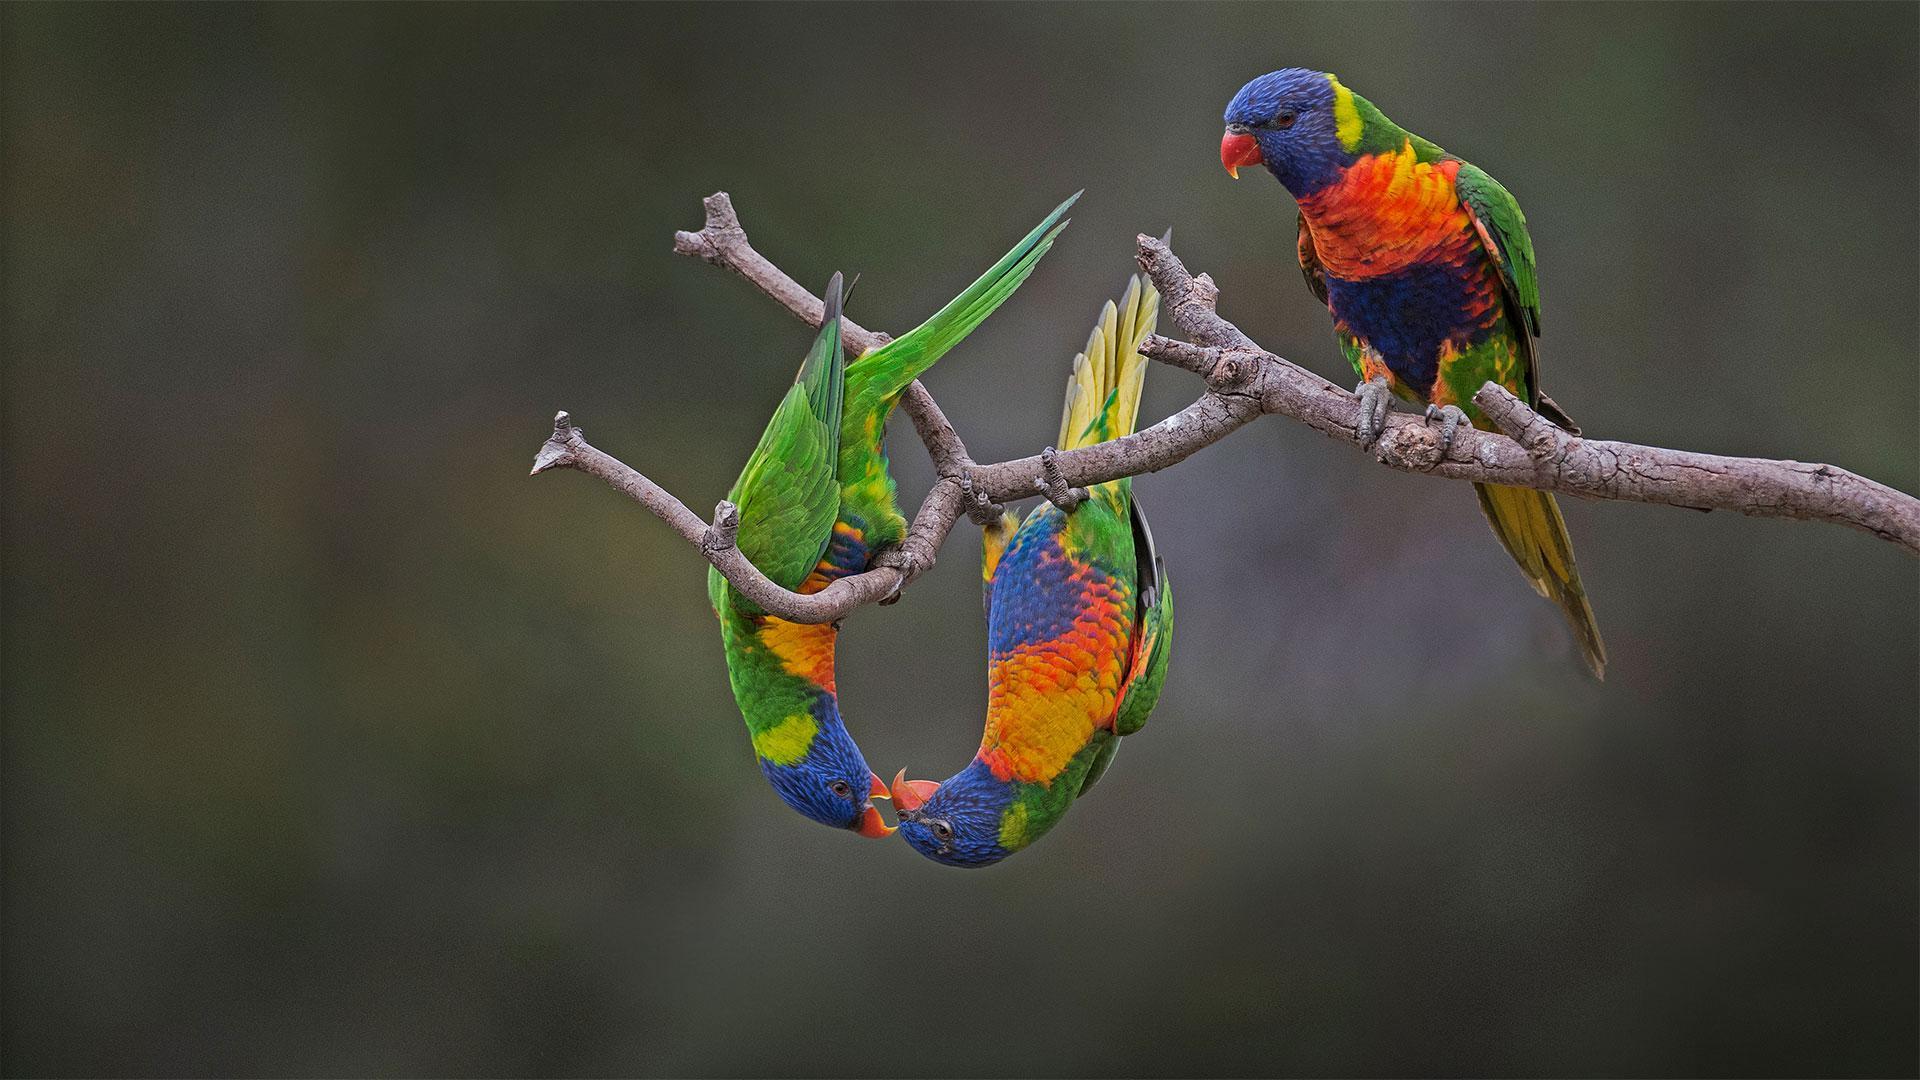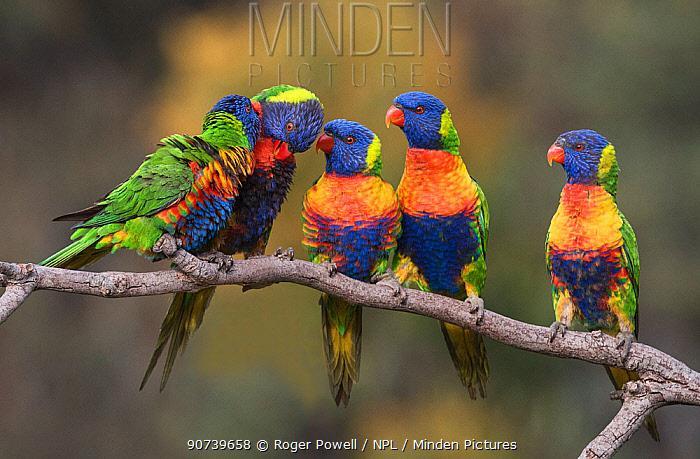The first image is the image on the left, the second image is the image on the right. Evaluate the accuracy of this statement regarding the images: "There are at most 4 birds shown.". Is it true? Answer yes or no. No. The first image is the image on the left, the second image is the image on the right. For the images displayed, is the sentence "there is exactly one bird in the image on the left" factually correct? Answer yes or no. No. 